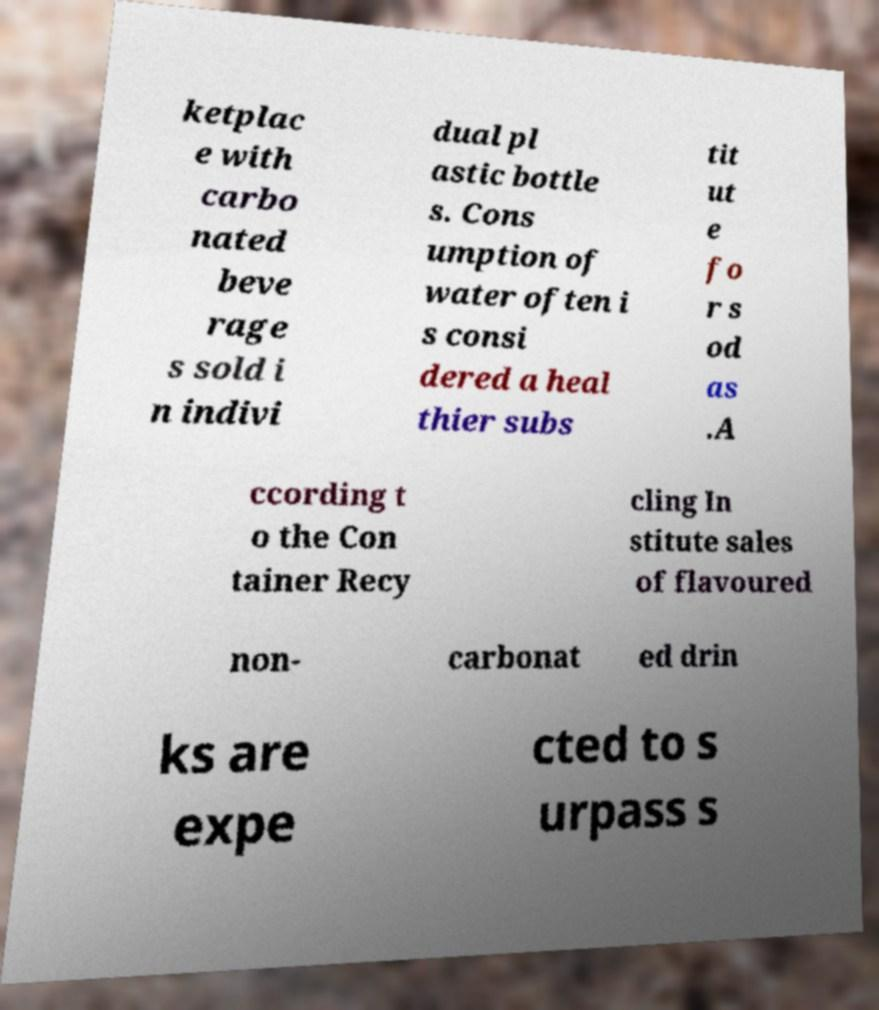Please read and relay the text visible in this image. What does it say? ketplac e with carbo nated beve rage s sold i n indivi dual pl astic bottle s. Cons umption of water often i s consi dered a heal thier subs tit ut e fo r s od as .A ccording t o the Con tainer Recy cling In stitute sales of flavoured non- carbonat ed drin ks are expe cted to s urpass s 